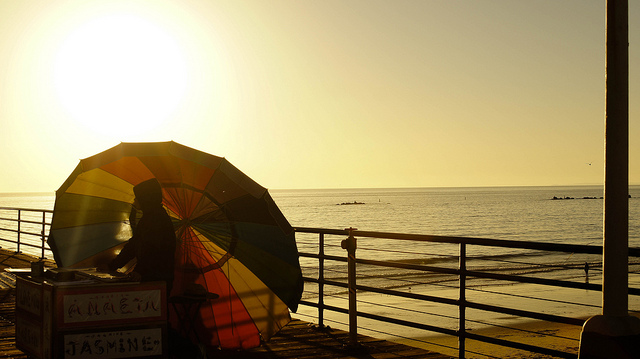What might the text on the cart indicate? The cart in the image has a sign with text that appears to be in a non-Latin script, possibly offering local goods or services such as beverages or food typical to the beach region it is located in. 